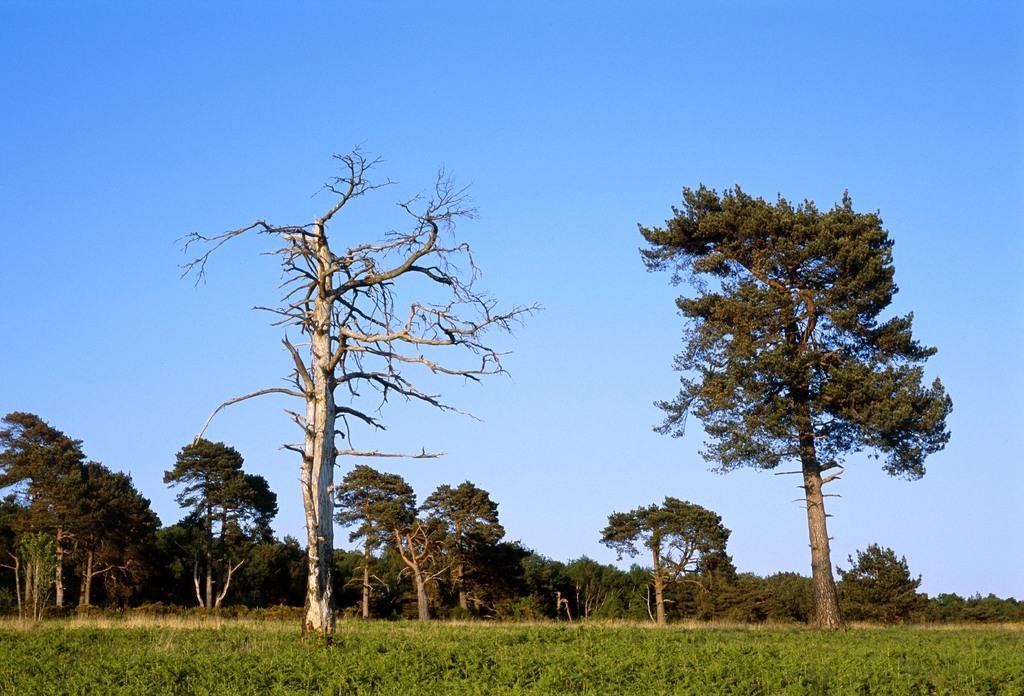In one or two sentences, can you explain what this image depicts? In this image we can see a group of trees. In that we can see a tree with dried branches. We can also see some plants and the sky which looks cloudy. 